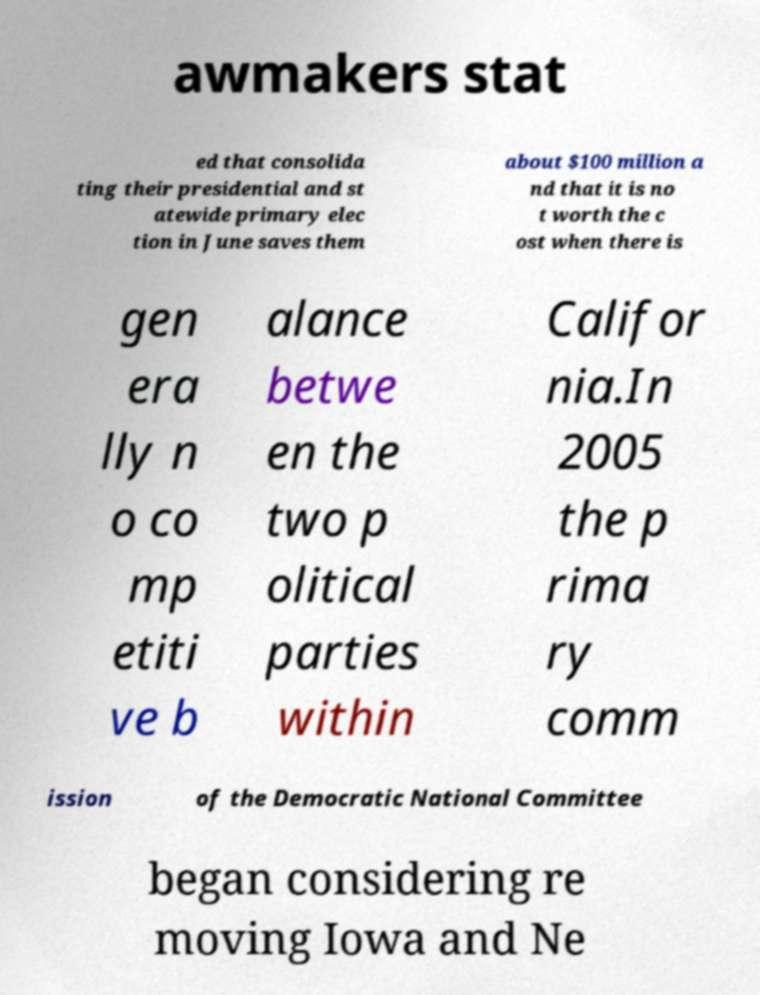Please identify and transcribe the text found in this image. awmakers stat ed that consolida ting their presidential and st atewide primary elec tion in June saves them about $100 million a nd that it is no t worth the c ost when there is gen era lly n o co mp etiti ve b alance betwe en the two p olitical parties within Califor nia.In 2005 the p rima ry comm ission of the Democratic National Committee began considering re moving Iowa and Ne 